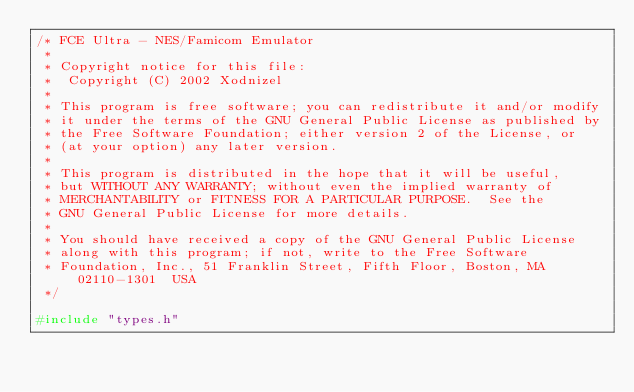<code> <loc_0><loc_0><loc_500><loc_500><_C++_>/* FCE Ultra - NES/Famicom Emulator
 *
 * Copyright notice for this file:
 *  Copyright (C) 2002 Xodnizel
 *
 * This program is free software; you can redistribute it and/or modify
 * it under the terms of the GNU General Public License as published by
 * the Free Software Foundation; either version 2 of the License, or
 * (at your option) any later version.
 *
 * This program is distributed in the hope that it will be useful,
 * but WITHOUT ANY WARRANTY; without even the implied warranty of
 * MERCHANTABILITY or FITNESS FOR A PARTICULAR PURPOSE.  See the
 * GNU General Public License for more details.
 *
 * You should have received a copy of the GNU General Public License
 * along with this program; if not, write to the Free Software
 * Foundation, Inc., 51 Franklin Street, Fifth Floor, Boston, MA  02110-1301  USA
 */

#include "types.h"</code> 